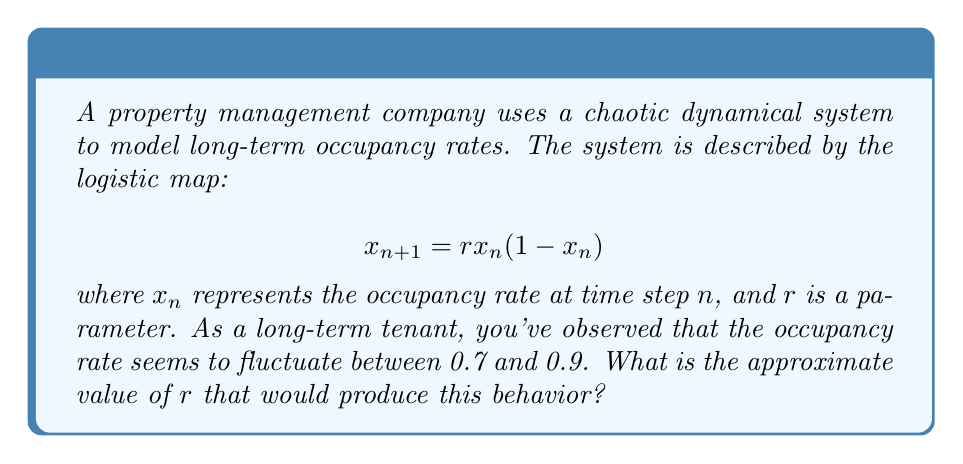Provide a solution to this math problem. To solve this problem, we need to understand the behavior of the logistic map for different values of $r$:

1. For $r$ between 3 and 3.57, the system oscillates between two values.
2. For $r$ greater than 3.57, the system enters a chaotic regime.

Given that the occupancy rate fluctuates between 0.7 and 0.9, we're looking for a value of $r$ in the chaotic regime.

3. In the chaotic regime, we can use the formula for the maximum value of $x_n$:

   $$x_{max} = 1 - \frac{1}{r}$$

4. We want $x_{max}$ to be approximately 0.9:

   $$0.9 = 1 - \frac{1}{r}$$

5. Solving for $r$:

   $$\frac{1}{r} = 1 - 0.9 = 0.1$$
   $$r = \frac{1}{0.1} = 10$$

6. To verify, we can check if this value of $r$ also produces a minimum around 0.7:

   $$x_{min} \approx \frac{r+1}{4r} = \frac{11}{40} = 0.275$$

   While this is lower than 0.7, it's important to note that in a chaotic system, not all values in the range are visited equally often. The system tends to spend more time near the extremes.

7. Therefore, $r = 10$ is a good approximation for the parameter that would produce the observed behavior.
Answer: $r \approx 10$ 